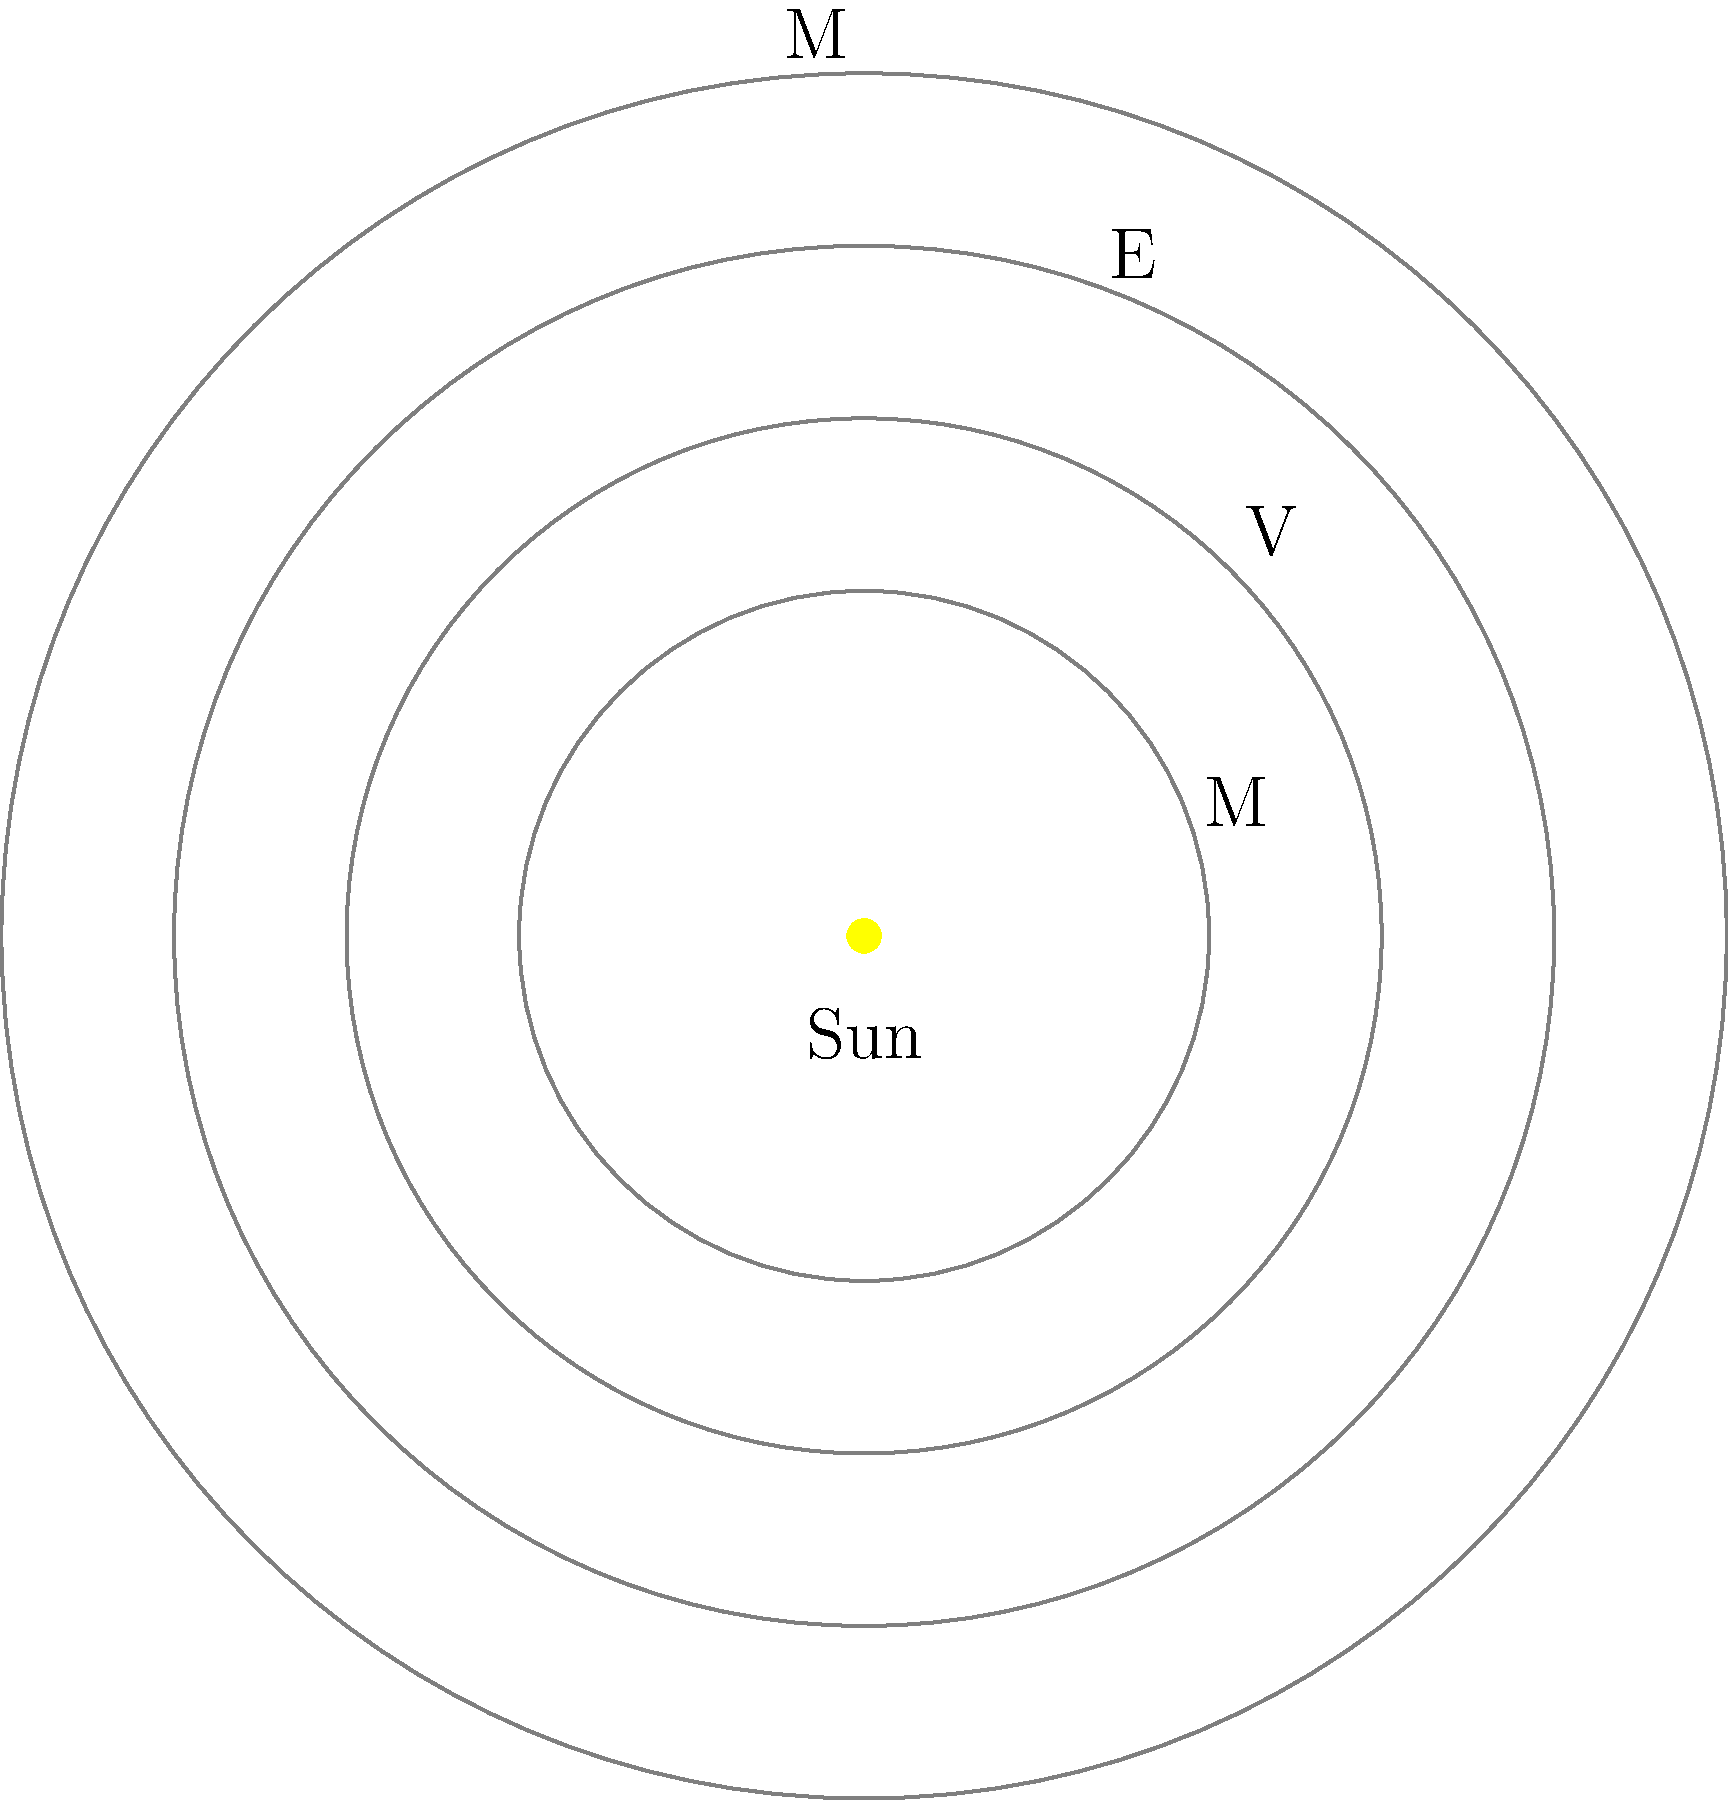In the simplified model of the Solar System shown above, which planet's orbit is most likely to represent Earth's? To determine which orbit most likely represents Earth's, we need to consider the following steps:

1. Recognize that the diagram is a simplified model of the inner Solar System.
2. Identify that the central yellow circle represents the Sun.
3. Count the number of orbits: there are 4 orbits shown.
4. Observe that the planets are labeled with single letters: M, V, E, and M.
5. Deduce that these letters likely stand for Mercury (M), Venus (V), Earth (E), and Mars (M).
6. Recall that Earth is the third planet from the Sun in our Solar System.
7. Count the orbits from the inside out: the first is likely Mercury, the second Venus, the third Earth, and the fourth Mars.
8. Locate the label "E" on the third orbit from the Sun.

Therefore, the third orbit from the Sun, which is labeled with "E", most likely represents Earth's orbit in this simplified model.
Answer: The third orbit from the Sun 